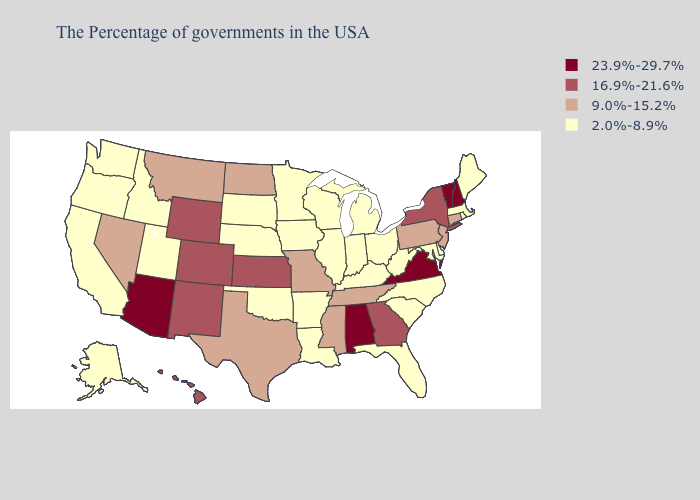Among the states that border Florida , does Alabama have the lowest value?
Quick response, please. No. What is the value of California?
Give a very brief answer. 2.0%-8.9%. What is the lowest value in states that border Washington?
Keep it brief. 2.0%-8.9%. Is the legend a continuous bar?
Keep it brief. No. What is the value of Utah?
Concise answer only. 2.0%-8.9%. What is the highest value in the West ?
Be succinct. 23.9%-29.7%. Among the states that border Rhode Island , does Massachusetts have the lowest value?
Write a very short answer. Yes. Name the states that have a value in the range 2.0%-8.9%?
Quick response, please. Maine, Massachusetts, Rhode Island, Delaware, Maryland, North Carolina, South Carolina, West Virginia, Ohio, Florida, Michigan, Kentucky, Indiana, Wisconsin, Illinois, Louisiana, Arkansas, Minnesota, Iowa, Nebraska, Oklahoma, South Dakota, Utah, Idaho, California, Washington, Oregon, Alaska. What is the lowest value in the Northeast?
Short answer required. 2.0%-8.9%. Name the states that have a value in the range 23.9%-29.7%?
Short answer required. New Hampshire, Vermont, Virginia, Alabama, Arizona. What is the value of Virginia?
Answer briefly. 23.9%-29.7%. Among the states that border Colorado , does Wyoming have the lowest value?
Keep it brief. No. Is the legend a continuous bar?
Write a very short answer. No. Does the map have missing data?
Answer briefly. No. 